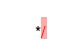Convert code to text. <code><loc_0><loc_0><loc_500><loc_500><_JavaScript_> */</code> 